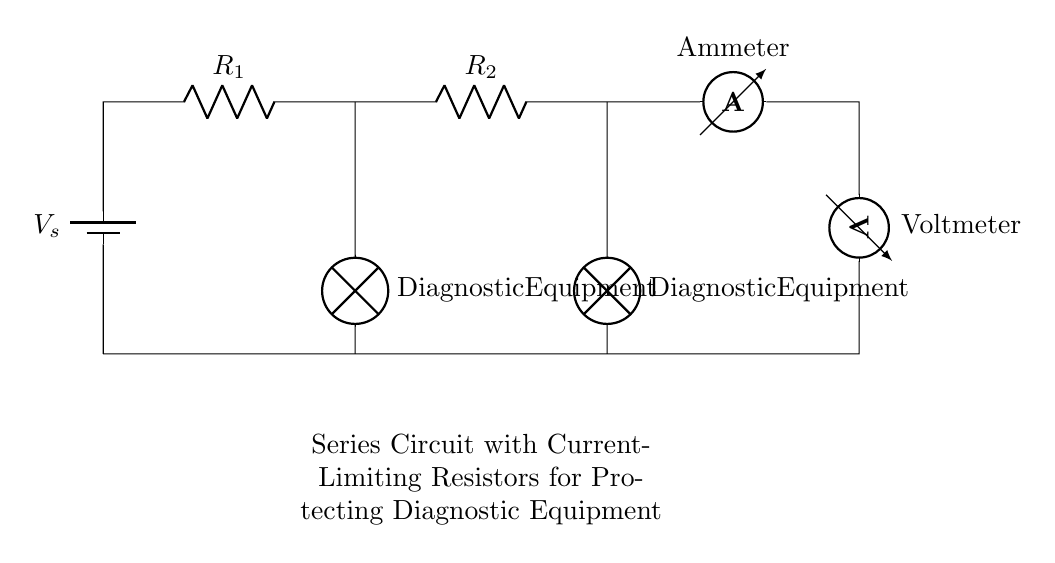What type of circuit is this? This circuit is a series circuit, which means the components are connected end-to-end such that the current flows through each component in a single pathway.
Answer: Series circuit What do the resistors do? The resistors limit the current flowing through the diagnostic equipment, preventing damage during maintenance checks. They control the current by providing resistance in the circuit.
Answer: Current limiting How many diagnostic equipment lamps are in this circuit? There are two diagnostic equipment lamps in the circuit. Each lamp is shown as a load that operates in line with the series connection of the circuit.
Answer: Two What is the purpose of the ammeter? The ammeter measures the current flowing through the circuit, providing information on how much current is being used by the diagnostic equipment and ensuring it operates within safe limits.
Answer: Measurement How are the voltage and current related in this series circuit? In a series circuit, the total voltage across the circuit is equal to the sum of the voltages across each component, and the current is the same through all components. This is a fundamental property of series circuits.
Answer: Ohm's law What component provides the voltage in this circuit? The battery provides the voltage in the circuit, supplying the electrical energy needed for current to flow through the components.
Answer: Battery 